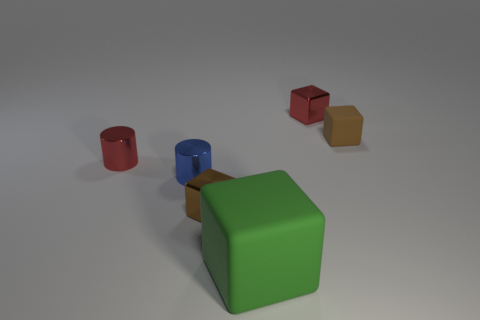There is a tiny cube that is on the left side of the brown matte thing and behind the red metal cylinder; what is its material? metal 